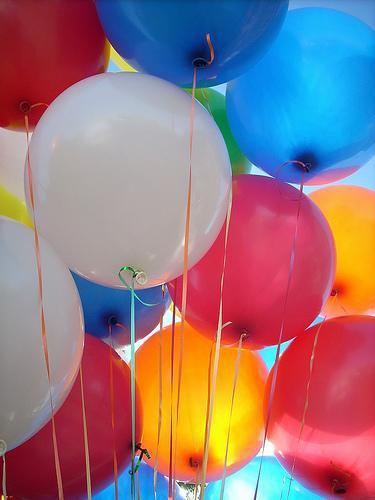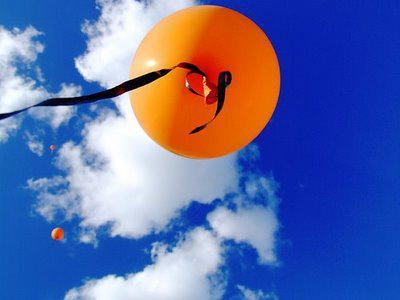The first image is the image on the left, the second image is the image on the right. Given the left and right images, does the statement "there are a bunch of balloons gathered together by strings and all the purple balloons are on the bottom" hold true? Answer yes or no. No. The first image is the image on the left, the second image is the image on the right. For the images shown, is this caption "An image shows an upward view of at least one balloon on a string ascending into a cloud-studded blue sky." true? Answer yes or no. Yes. 